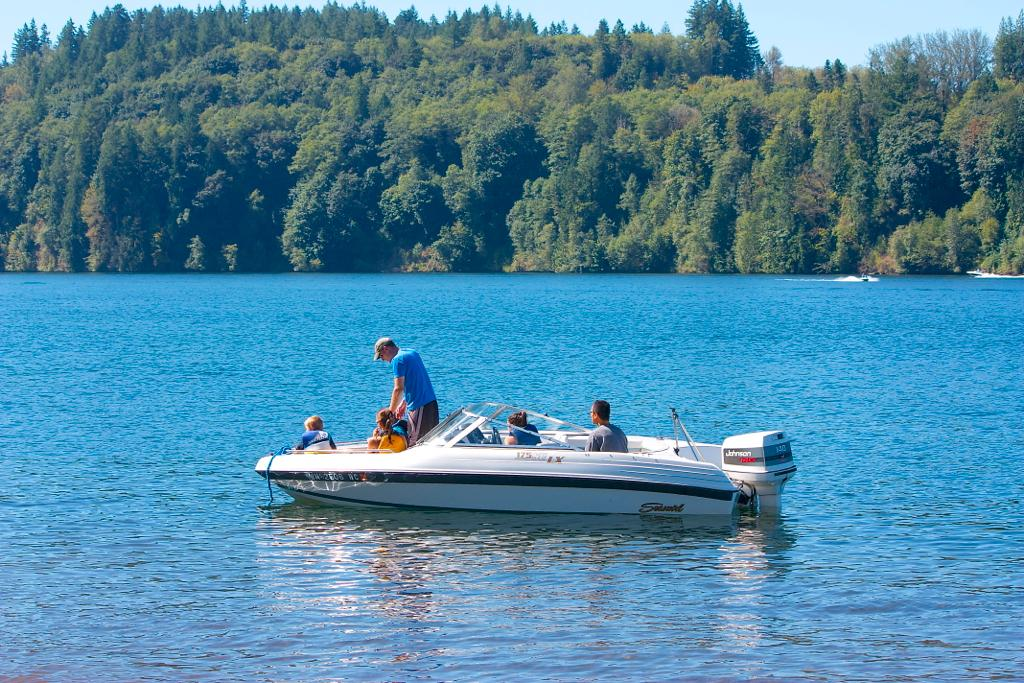What is in the water in the image? There is a boat in the water in the image. Who or what is inside the boat? There are people seated in the boat. What can be seen in the background of the image? There are trees visible in the background. What type of vein is visible in the image? There is no vein visible in the image; it features a boat in the water with people seated inside and trees in the background. 